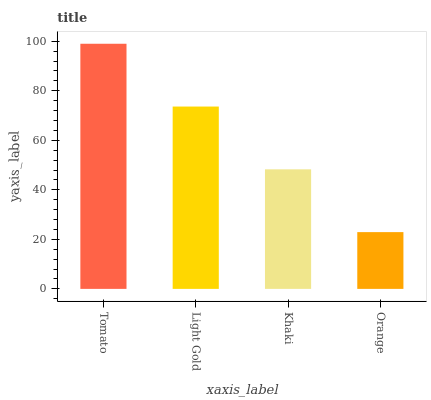Is Orange the minimum?
Answer yes or no. Yes. Is Tomato the maximum?
Answer yes or no. Yes. Is Light Gold the minimum?
Answer yes or no. No. Is Light Gold the maximum?
Answer yes or no. No. Is Tomato greater than Light Gold?
Answer yes or no. Yes. Is Light Gold less than Tomato?
Answer yes or no. Yes. Is Light Gold greater than Tomato?
Answer yes or no. No. Is Tomato less than Light Gold?
Answer yes or no. No. Is Light Gold the high median?
Answer yes or no. Yes. Is Khaki the low median?
Answer yes or no. Yes. Is Tomato the high median?
Answer yes or no. No. Is Tomato the low median?
Answer yes or no. No. 